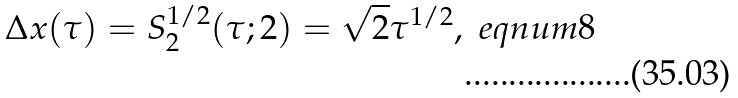<formula> <loc_0><loc_0><loc_500><loc_500>\Delta x ( \tau ) = S _ { 2 } ^ { 1 / 2 } ( \tau ; 2 ) = \sqrt { 2 } \tau ^ { 1 / 2 } , \ e q n u m { 8 }</formula> 